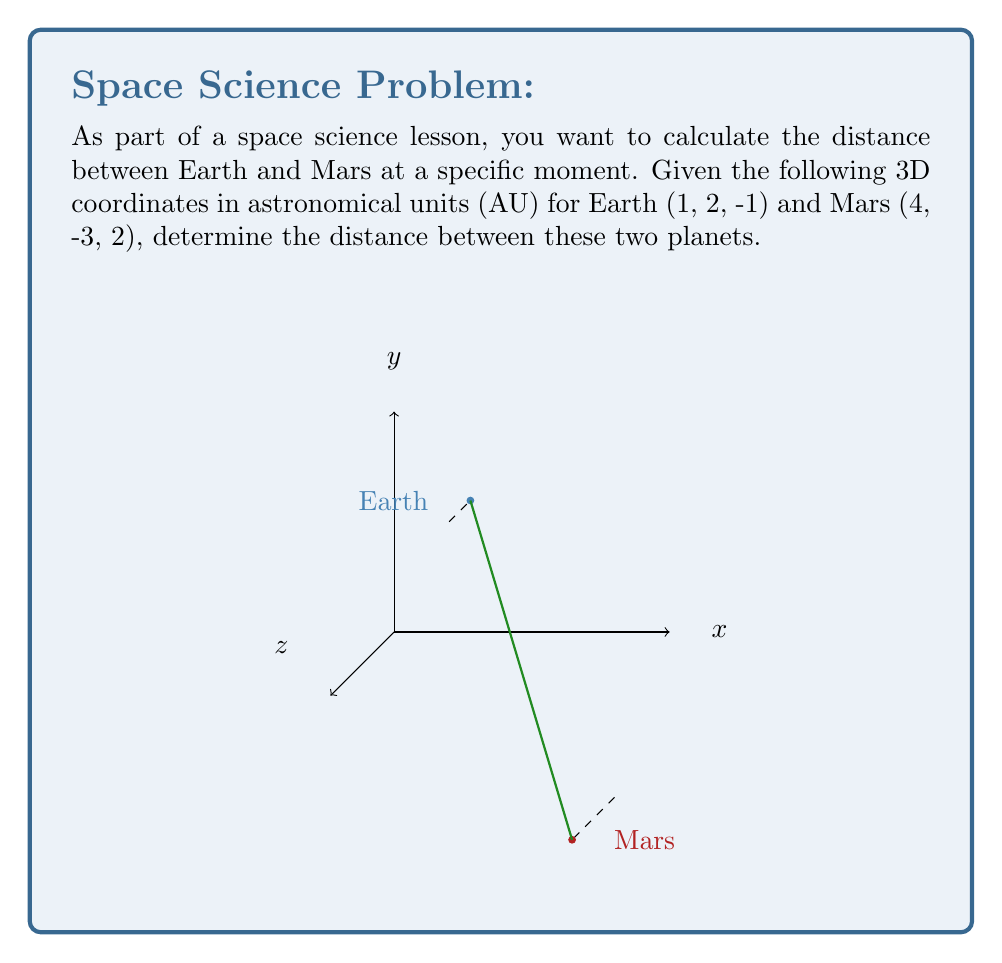Help me with this question. To calculate the distance between two points in 3D space, we use the distance formula derived from the Pythagorean theorem:

$$d = \sqrt{(x_2-x_1)^2 + (y_2-y_1)^2 + (z_2-z_1)^2}$$

Where $(x_1, y_1, z_1)$ are the coordinates of the first point (Earth) and $(x_2, y_2, z_2)$ are the coordinates of the second point (Mars).

Given:
Earth: $(1, 2, -1)$
Mars: $(4, -3, 2)$

Let's substitute these values into the formula:

$$\begin{align}
d &= \sqrt{(4-1)^2 + (-3-2)^2 + (2-(-1))^2} \\
&= \sqrt{3^2 + (-5)^2 + 3^2} \\
&= \sqrt{9 + 25 + 9} \\
&= \sqrt{43}
\end{align}$$

The distance between Earth and Mars is $\sqrt{43}$ astronomical units (AU).
Answer: $\sqrt{43}$ AU 